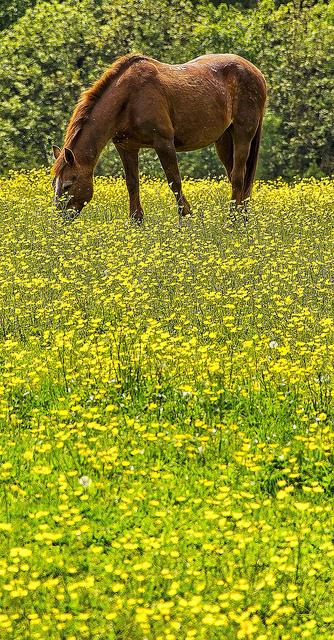Is the horse trying to eat flowers?
Concise answer only. Yes. Does the animal appear content?
Answer briefly. Yes. Are these wild flowers?
Keep it brief. Yes. 